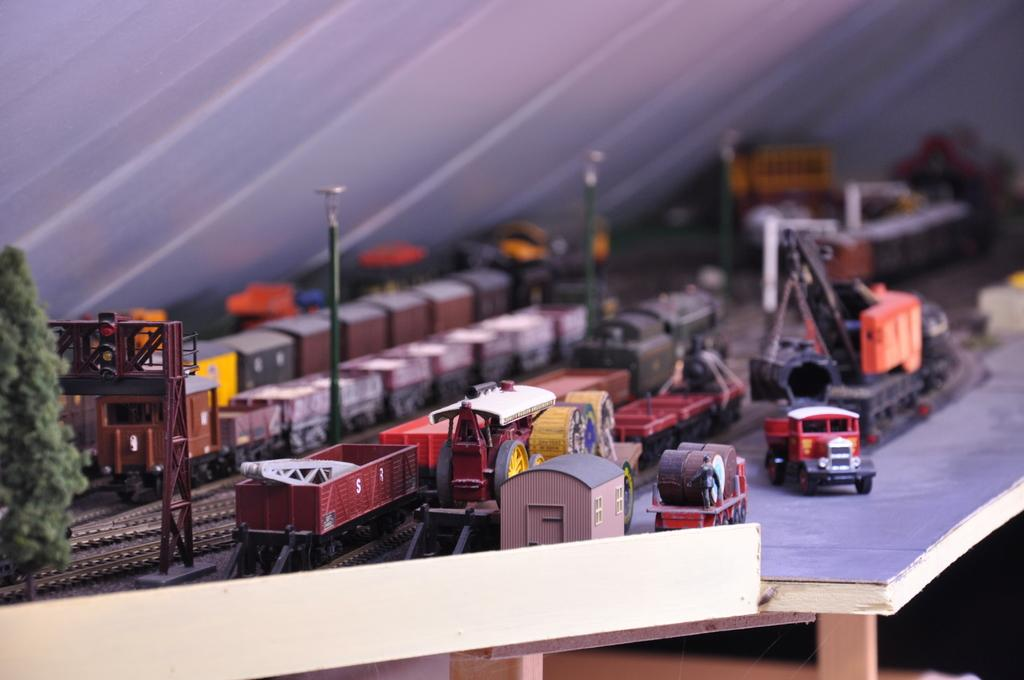What type of toys are present in the image? There are toy trains in the image. What other types of vehicles can be seen in the image? There are trucks in the image. What kind of natural elements are visible in the image? There are trees in the image. Where are all of these objects located? All of these objects are on a table. What type of war is depicted in the image? There is no war depicted in the image; it features toy trains, trucks, and trees on a table. What kind of art can be seen in the image? There is no art present in the image; it features toy trains, trucks, and trees on a table. 